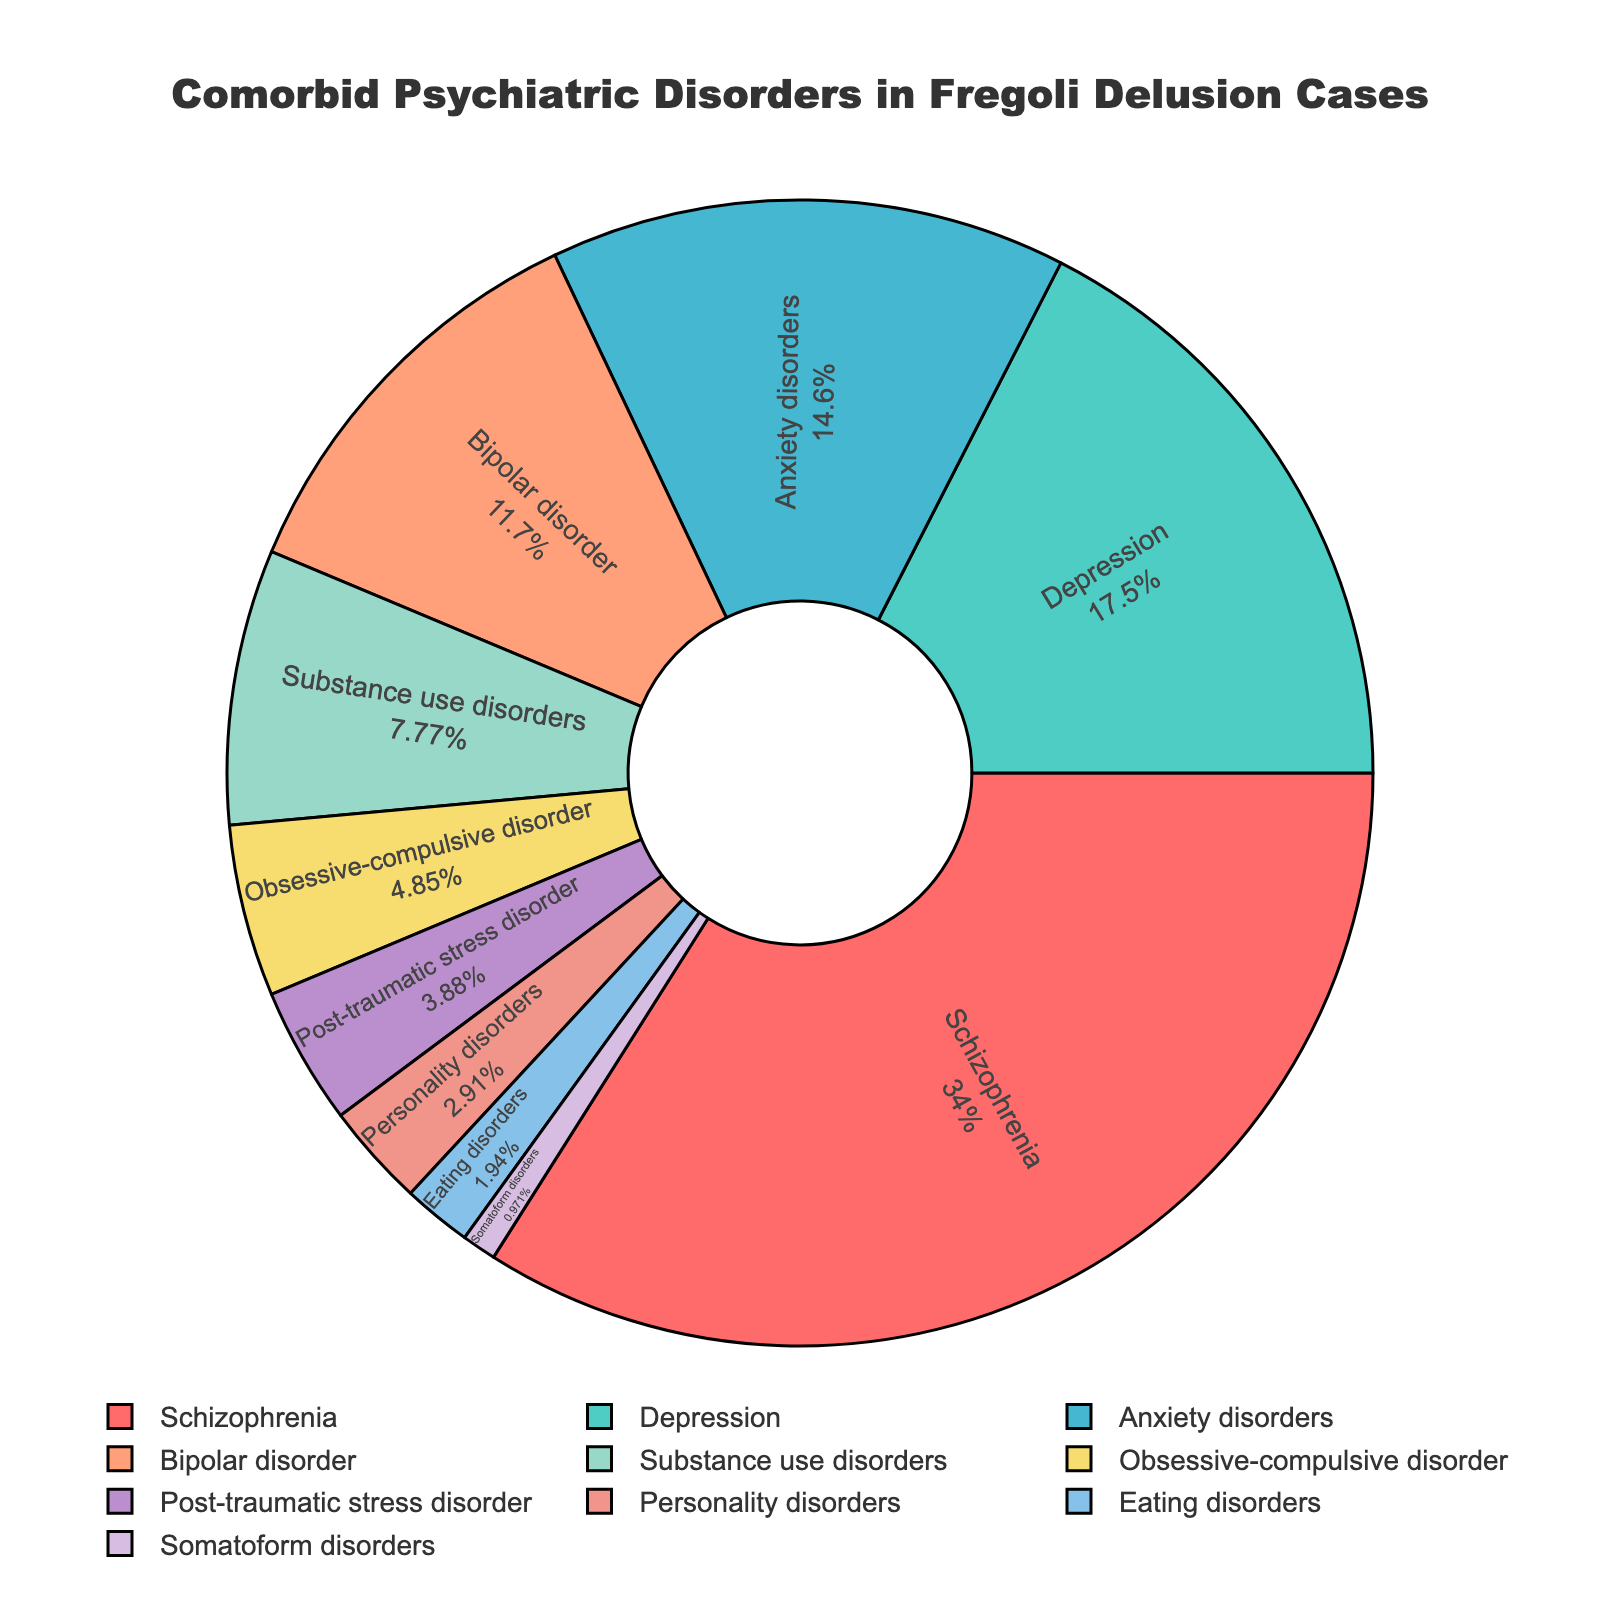What is the most common comorbid psychiatric disorder in Fregoli delusion cases? The most common comorbid psychiatric disorder can be identified by looking at the largest portion of the pie chart. Schizophrenia occupies the largest section with 35%.
Answer: Schizophrenia What percentage of Fregoli delusion cases involve anxiety disorders? Referring to the segment labeled "Anxiety disorders", the percentage is provided within it. It is 15%.
Answer: 15% Which comorbid disorder has the smallest representation in Fregoli delusion cases? The smallest segment in the pie chart corresponds to Somatoform disorders, with a percentage of 1%.
Answer: Somatoform disorders What is the combined percentage of depression and bipolar disorder in Fregoli delusion cases? The percentage for depression is 18% and for bipolar disorder is 12%. Adding these together, 18% + 12% = 30%.
Answer: 30% Which disorder has a higher percentage, substance use disorders or obsessive-compulsive disorder? Comparing the segments, Substance use disorders have a percentage of 8%, while Obsessive-compulsive disorder has a percentage of 5%. 8% is higher than 5%.
Answer: Substance use disorders What is the total percentage represented by all the disorders listed except schizophrenia? The total percentage except for schizophrenia is calculated by adding the percentages of all other disorders: 18% + 15% + 12% + 8% + 5% + 4% + 3% + 2% + 1% = 68%.
Answer: 65% How does the percentage of depression compare to that of eating disorders? Depression represents 18% and Eating disorders represent 2%. 18% is significantly greater than 2%.
Answer: Depression What is the combined percentage of disorders that individually constitute less than 5%? Adding the percentages for each disorder that constitutes less than 5%: Obsessive-compulsive disorder (5%), Post-traumatic stress disorder (4%), Personality disorders (3%), Eating disorders (2%), and Somatoform disorders (1%). Total = 5% + 4% + 3% + 2% + 1% = 15%.
Answer: 15% What percentage of Fregoli delusion cases involve personality disorders or eating disorders? The percentage of Personality disorders is 3% and Eating disorders is 2%. Combining these, 3% + 2% = 5%.
Answer: 5% What is the difference between the percentage of anxiety disorders and post-traumatic stress disorder? Anxiety disorders constitute 15% and Post-traumatic stress disorder constitutes 4%. The difference is calculated as 15% - 4% = 11%.
Answer: 11% 